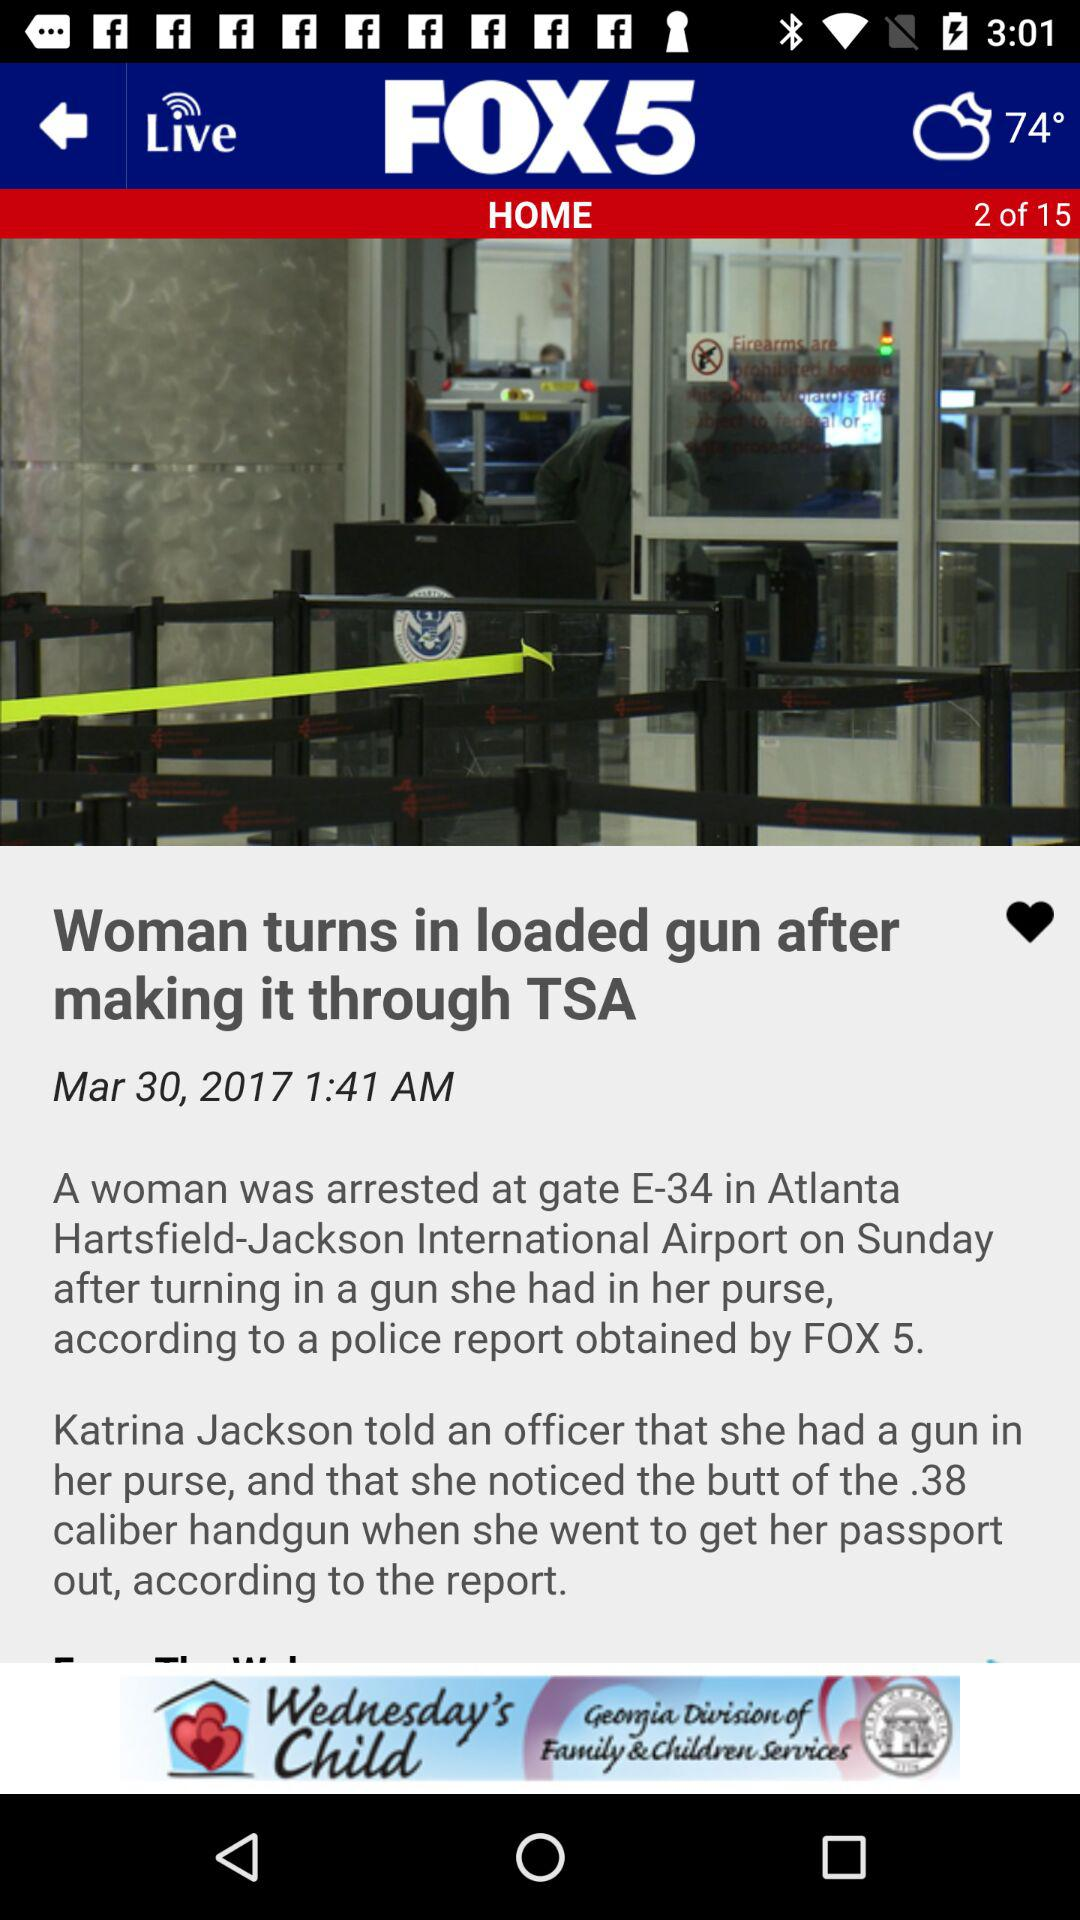What is the publication date and time? The publication date is March 30, 2017 and the publication time is 1:41 a.m. 